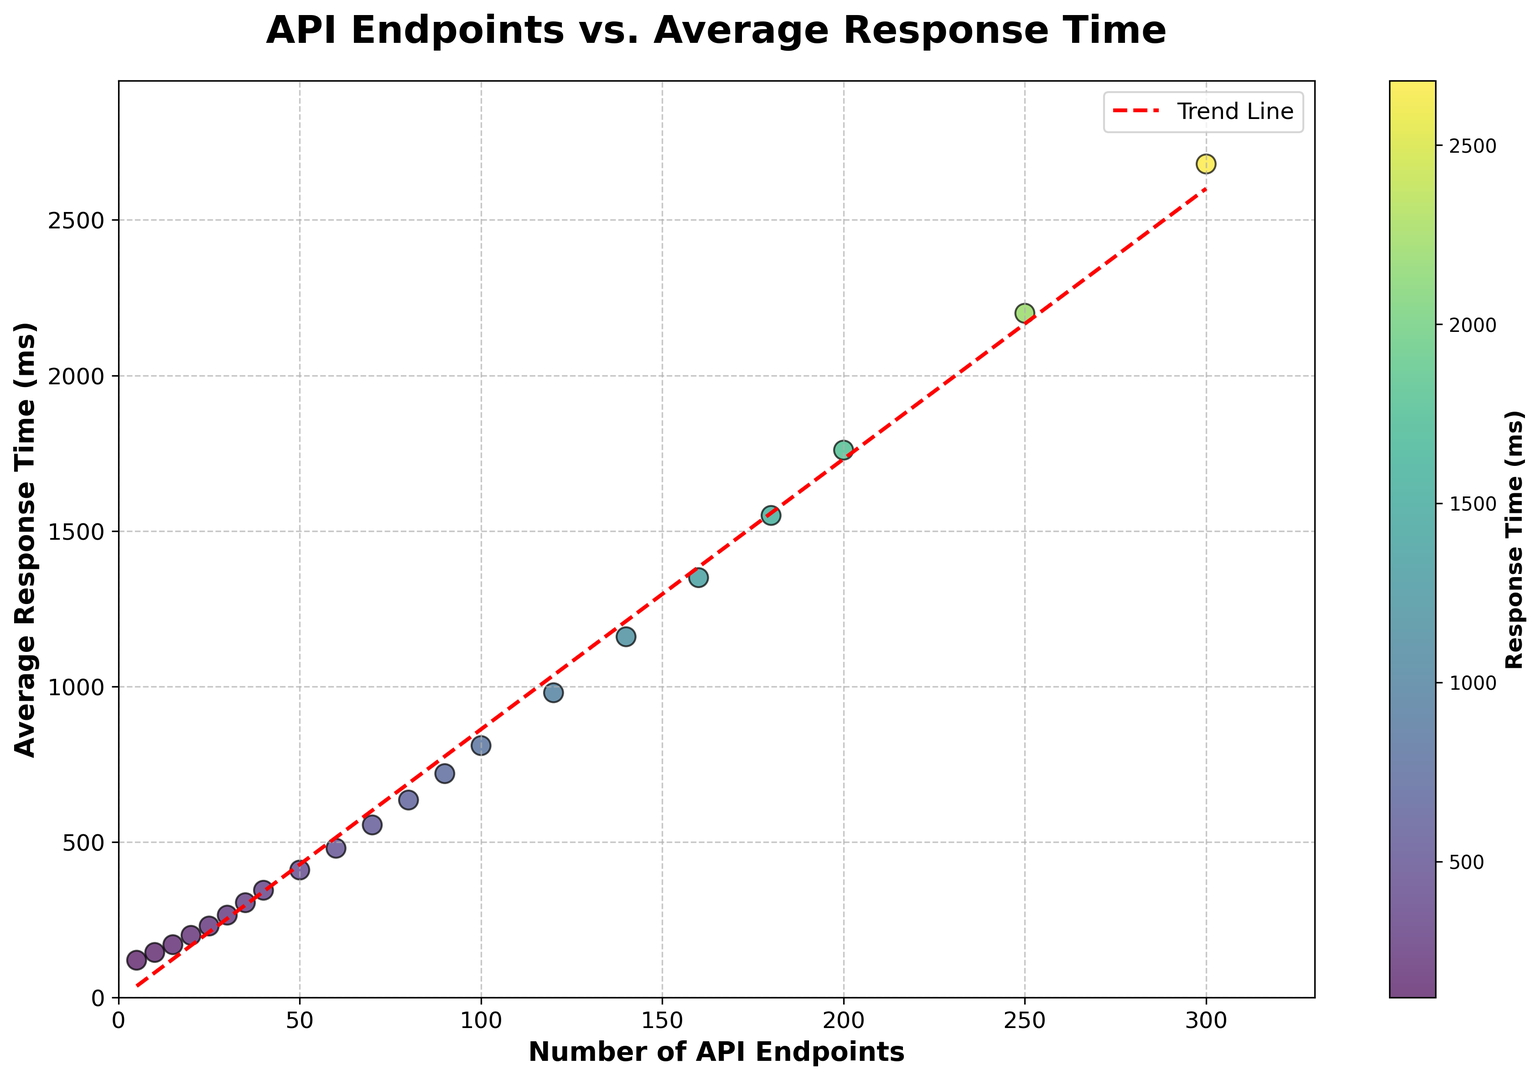What's the average response time for 100 API endpoints? To find the average response time, locate the point where the "Number of API Endpoints" is 100 on the x-axis. The corresponding y-value is 810 ms.
Answer: 810 ms Is the response time for 200 API endpoints less than double the response time for 100 API endpoints? Double the response time for 100 API endpoints is 2 * 810 = 1620 ms. The response time for 200 API endpoints, as shown in the plot, is 1760 ms. Therefore, 1760 ms is not less than 1620 ms.
Answer: No Which range of API endpoints shows the steepest increase in response time? Examine the slope of the trend line or compare the vertical distance between successive points. The steepest increase appears between 250 and 300 API endpoints, where the response time jumps significantly.
Answer: 250 to 300 API endpoints By how much does the response time increase between 80 and 100 API endpoints? The response time at 80 API endpoints is 635 ms, and at 100 API endpoints, it is 810 ms. The increase is 810 - 635 = 175 ms.
Answer: 175 ms How does the response time change as the number of API endpoints increases from 60 to 120? To determine the change, compare the y-values: 480 ms for 60 API endpoints and 980 ms for 120 API endpoints. Thus, the response time increases by 980 - 480 = 500 ms.
Answer: 500 ms What is the trend in response time as the number of API endpoints increases? Observing the trend line (red dashed line), the response time generally increases linearly as the number of API endpoints increases.
Answer: Increases linearly Is there a significant deviation from the trend line at any data point? Look for points that are significantly above or below the trend line. The data appears close to the trend line with consistent behavior, showing no significant deviation.
Answer: No Is the color associated with the response time, and how does it change? The scatter plot uses a color gradient to represent response times. As response times increase, the color transitions from green to yellow.
Answer: From green to yellow For which number of API endpoints does the response time first exceed 1000 ms? Locate the point where the y-value first exceeds 1000 ms. This occurs at 120 API endpoints, where the response time is 980 ms, and then exceeds 1000 ms at 140 endpoints (1160 ms).
Answer: 140 API endpoints 